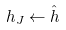<formula> <loc_0><loc_0><loc_500><loc_500>h _ { J } \leftarrow \hat { h }</formula> 